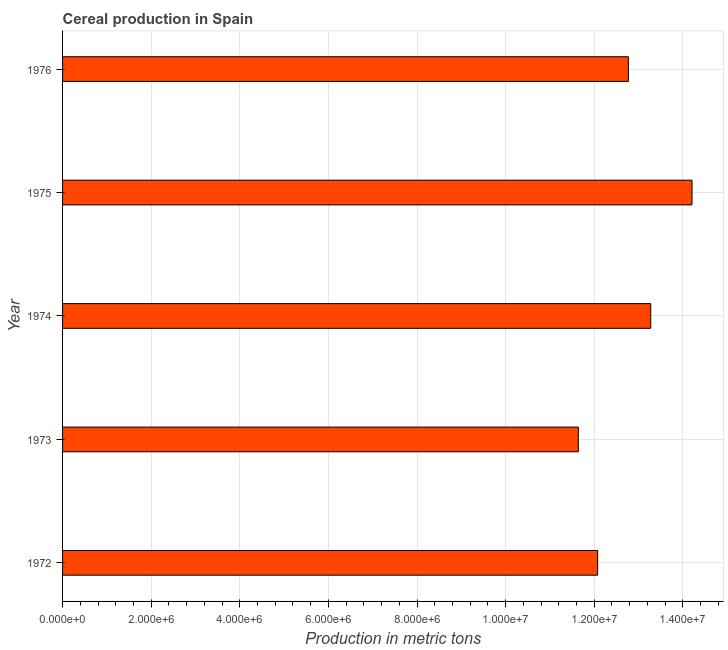What is the title of the graph?
Make the answer very short. Cereal production in Spain. What is the label or title of the X-axis?
Provide a succinct answer. Production in metric tons. What is the cereal production in 1973?
Make the answer very short. 1.16e+07. Across all years, what is the maximum cereal production?
Provide a succinct answer. 1.42e+07. Across all years, what is the minimum cereal production?
Your response must be concise. 1.16e+07. In which year was the cereal production maximum?
Your response must be concise. 1975. In which year was the cereal production minimum?
Your answer should be very brief. 1973. What is the sum of the cereal production?
Offer a terse response. 6.40e+07. What is the difference between the cereal production in 1973 and 1974?
Offer a very short reply. -1.63e+06. What is the average cereal production per year?
Your answer should be very brief. 1.28e+07. What is the median cereal production?
Provide a succinct answer. 1.28e+07. Do a majority of the years between 1976 and 1975 (inclusive) have cereal production greater than 8800000 metric tons?
Offer a very short reply. No. What is the ratio of the cereal production in 1975 to that in 1976?
Ensure brevity in your answer.  1.11. Is the cereal production in 1975 less than that in 1976?
Offer a terse response. No. Is the difference between the cereal production in 1972 and 1975 greater than the difference between any two years?
Offer a very short reply. No. What is the difference between the highest and the second highest cereal production?
Your response must be concise. 9.32e+05. Is the sum of the cereal production in 1972 and 1973 greater than the maximum cereal production across all years?
Offer a very short reply. Yes. What is the difference between the highest and the lowest cereal production?
Ensure brevity in your answer.  2.57e+06. How many bars are there?
Offer a very short reply. 5. What is the difference between two consecutive major ticks on the X-axis?
Your answer should be very brief. 2.00e+06. Are the values on the major ticks of X-axis written in scientific E-notation?
Your answer should be very brief. Yes. What is the Production in metric tons in 1972?
Keep it short and to the point. 1.21e+07. What is the Production in metric tons in 1973?
Provide a short and direct response. 1.16e+07. What is the Production in metric tons of 1974?
Offer a very short reply. 1.33e+07. What is the Production in metric tons of 1975?
Provide a short and direct response. 1.42e+07. What is the Production in metric tons in 1976?
Ensure brevity in your answer.  1.28e+07. What is the difference between the Production in metric tons in 1972 and 1973?
Your answer should be compact. 4.35e+05. What is the difference between the Production in metric tons in 1972 and 1974?
Provide a short and direct response. -1.20e+06. What is the difference between the Production in metric tons in 1972 and 1975?
Offer a very short reply. -2.13e+06. What is the difference between the Production in metric tons in 1972 and 1976?
Your response must be concise. -6.94e+05. What is the difference between the Production in metric tons in 1973 and 1974?
Your answer should be very brief. -1.63e+06. What is the difference between the Production in metric tons in 1973 and 1975?
Your answer should be very brief. -2.57e+06. What is the difference between the Production in metric tons in 1973 and 1976?
Offer a very short reply. -1.13e+06. What is the difference between the Production in metric tons in 1974 and 1975?
Ensure brevity in your answer.  -9.32e+05. What is the difference between the Production in metric tons in 1974 and 1976?
Keep it short and to the point. 5.04e+05. What is the difference between the Production in metric tons in 1975 and 1976?
Provide a short and direct response. 1.44e+06. What is the ratio of the Production in metric tons in 1972 to that in 1973?
Provide a short and direct response. 1.04. What is the ratio of the Production in metric tons in 1972 to that in 1974?
Offer a terse response. 0.91. What is the ratio of the Production in metric tons in 1972 to that in 1976?
Your answer should be compact. 0.95. What is the ratio of the Production in metric tons in 1973 to that in 1974?
Offer a terse response. 0.88. What is the ratio of the Production in metric tons in 1973 to that in 1975?
Provide a short and direct response. 0.82. What is the ratio of the Production in metric tons in 1973 to that in 1976?
Your answer should be very brief. 0.91. What is the ratio of the Production in metric tons in 1974 to that in 1975?
Keep it short and to the point. 0.93. What is the ratio of the Production in metric tons in 1974 to that in 1976?
Your answer should be compact. 1.04. What is the ratio of the Production in metric tons in 1975 to that in 1976?
Ensure brevity in your answer.  1.11. 